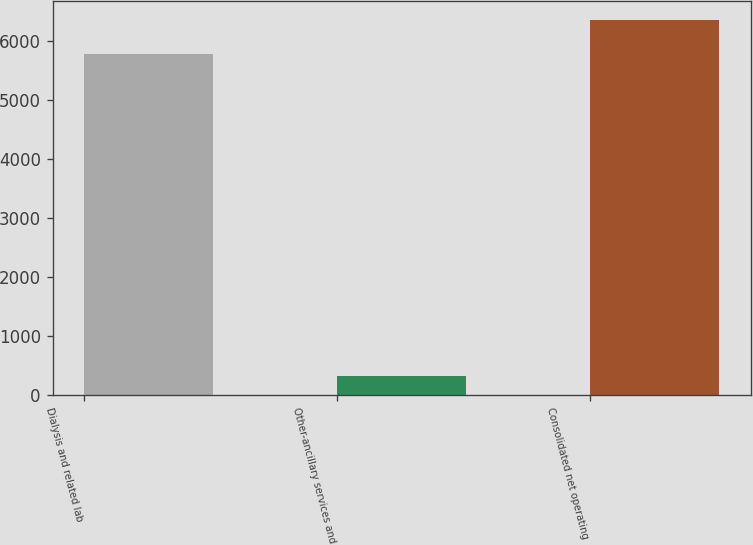<chart> <loc_0><loc_0><loc_500><loc_500><bar_chart><fcel>Dialysis and related lab<fcel>Other-ancillary services and<fcel>Consolidated net operating<nl><fcel>5792<fcel>317<fcel>6371.2<nl></chart> 